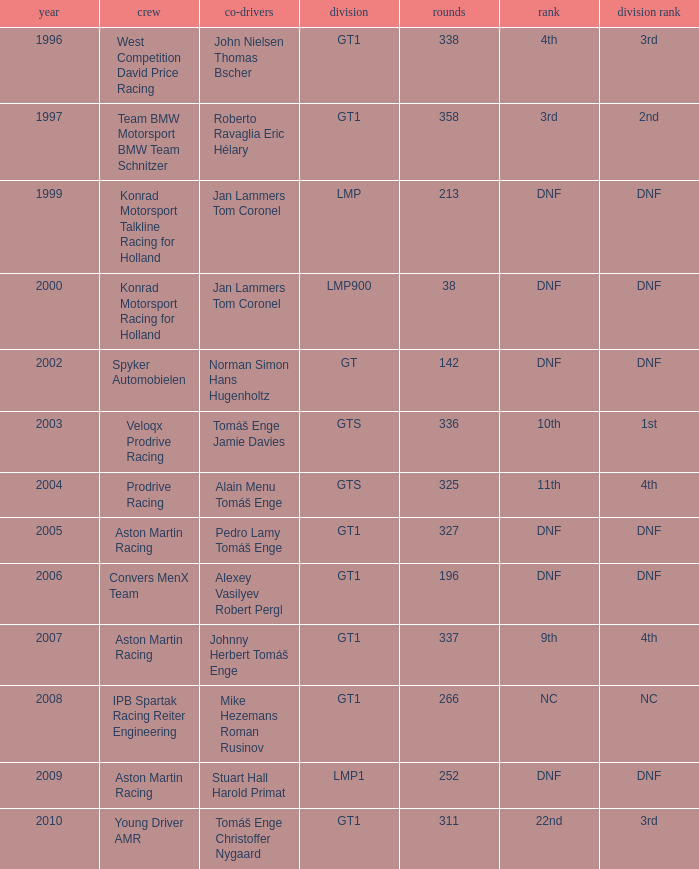In which class had 252 laps and a position of dnf? LMP1. 